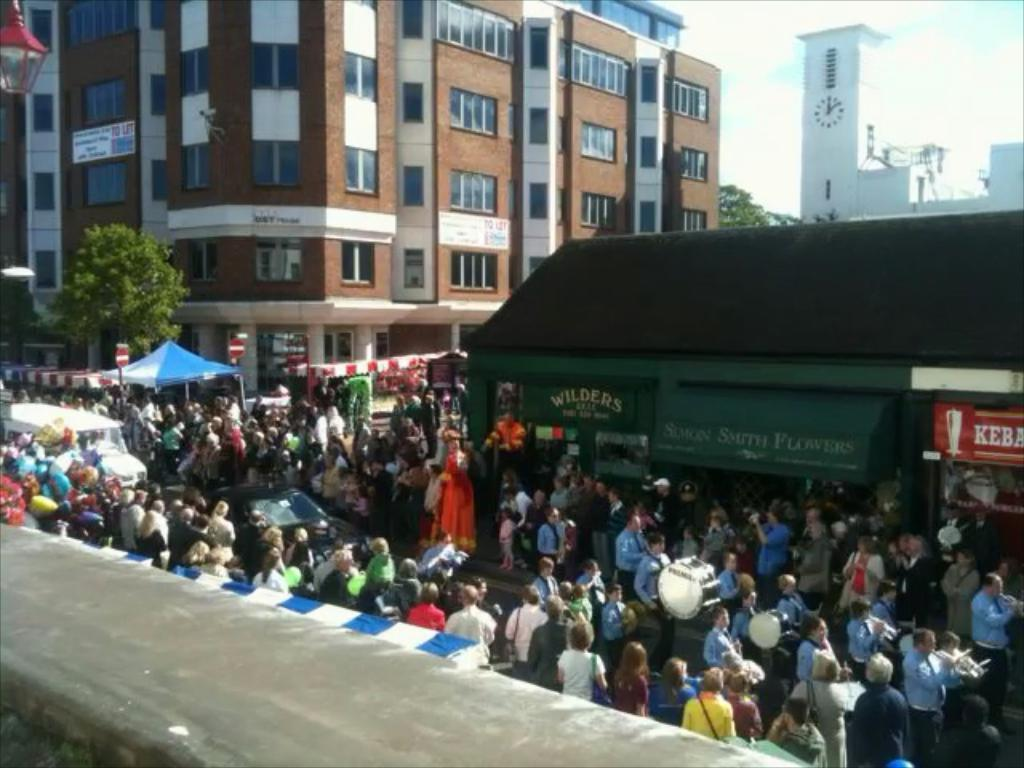What type of structures can be seen in the image? There are buildings in the image. What other natural elements are present in the image? There are trees in the image. Are there any living beings visible in the image? Yes, there are people standing in the image. What mode of transportation can be seen in the image? There is a vehicle in the image. What activity are some people engaged in on the right side of the image? People are playing musical instruments on the right side of the image. Can you see a cloud floating above the people playing musical instruments in the image? There is no mention of a cloud in the image, so we cannot confirm its presence. Are the people in the image taking a selfie with a balloon? There is no indication of a selfie or a balloon in the image. 